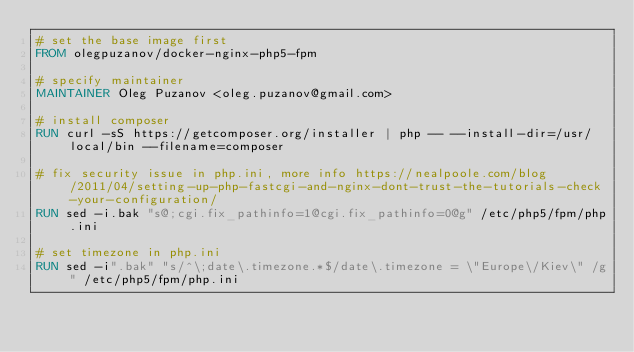<code> <loc_0><loc_0><loc_500><loc_500><_Dockerfile_># set the base image first
FROM olegpuzanov/docker-nginx-php5-fpm

# specify maintainer
MAINTAINER Oleg Puzanov <oleg.puzanov@gmail.com>

# install composer
RUN curl -sS https://getcomposer.org/installer | php -- --install-dir=/usr/local/bin --filename=composer

# fix security issue in php.ini, more info https://nealpoole.com/blog/2011/04/setting-up-php-fastcgi-and-nginx-dont-trust-the-tutorials-check-your-configuration/
RUN sed -i.bak "s@;cgi.fix_pathinfo=1@cgi.fix_pathinfo=0@g" /etc/php5/fpm/php.ini

# set timezone in php.ini
RUN sed -i".bak" "s/^\;date\.timezone.*$/date\.timezone = \"Europe\/Kiev\" /g" /etc/php5/fpm/php.ini</code> 